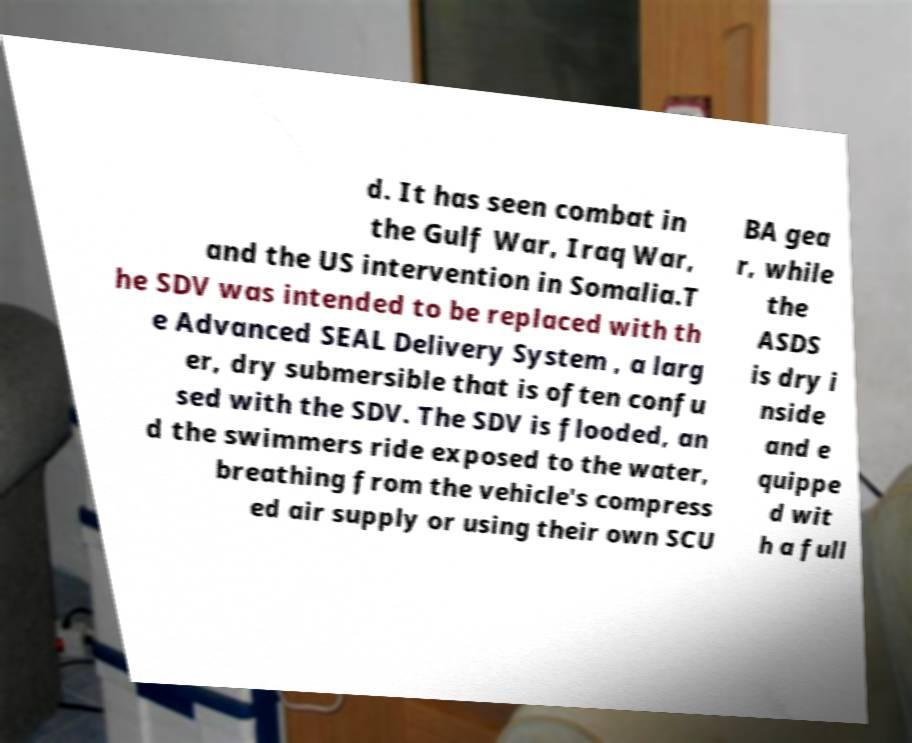What messages or text are displayed in this image? I need them in a readable, typed format. d. It has seen combat in the Gulf War, Iraq War, and the US intervention in Somalia.T he SDV was intended to be replaced with th e Advanced SEAL Delivery System , a larg er, dry submersible that is often confu sed with the SDV. The SDV is flooded, an d the swimmers ride exposed to the water, breathing from the vehicle's compress ed air supply or using their own SCU BA gea r, while the ASDS is dry i nside and e quippe d wit h a full 